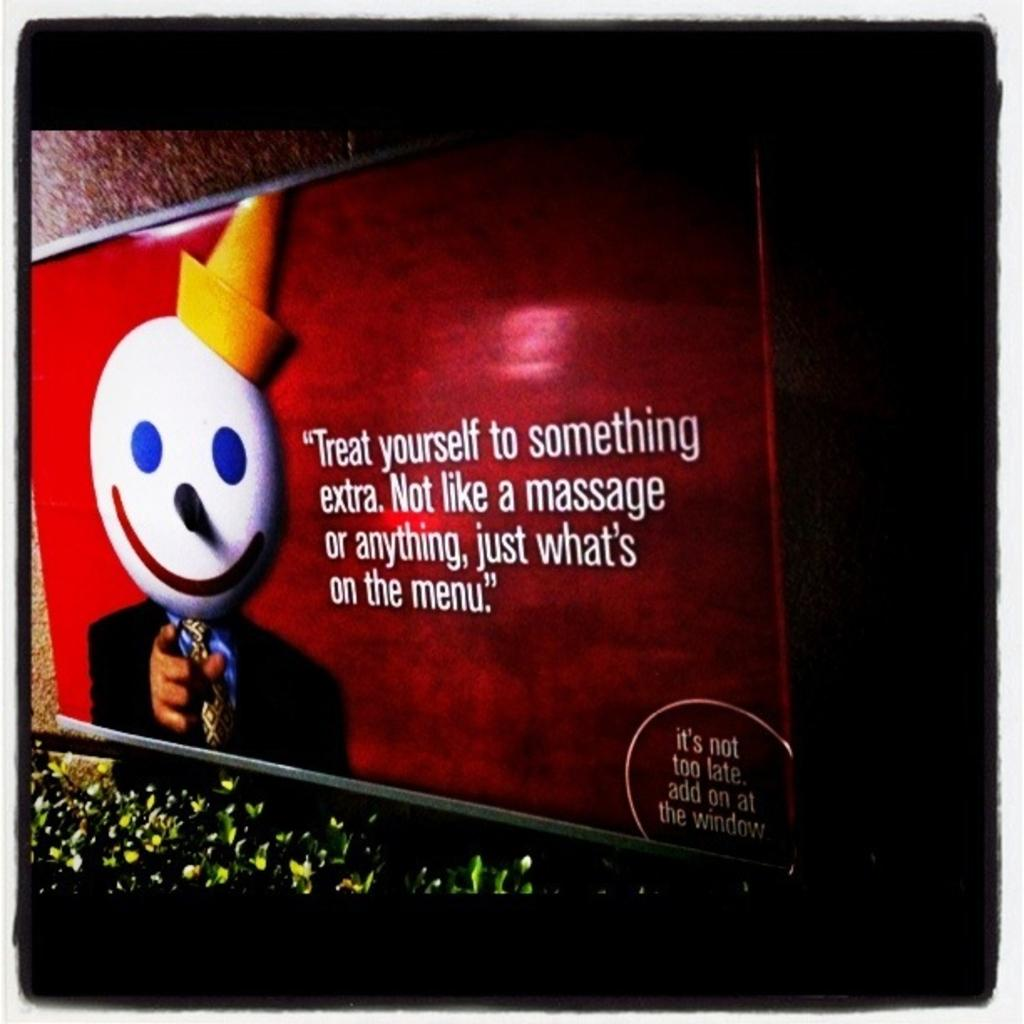What is placed on the wall in the image? There is a board placed on the wall in the image. What can be seen at the bottom of the image? There are plants at the bottom of the image. What type of smile can be seen on the plants in the image? There is no smile present on the plants in the image, as plants do not have facial expressions. 